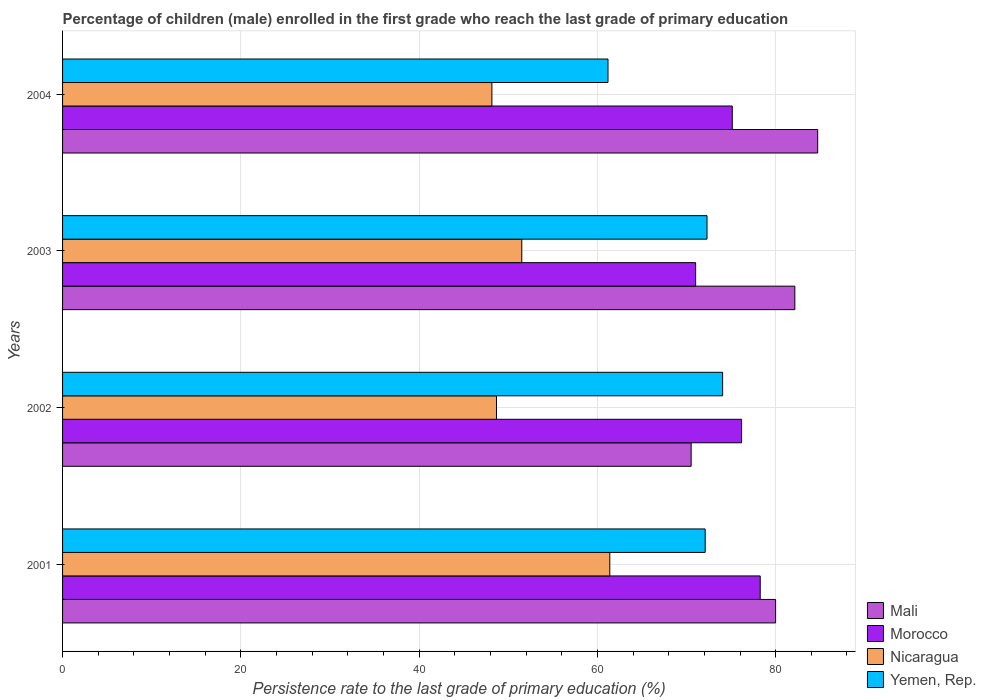How many groups of bars are there?
Provide a succinct answer. 4. How many bars are there on the 2nd tick from the bottom?
Offer a terse response. 4. In how many cases, is the number of bars for a given year not equal to the number of legend labels?
Your response must be concise. 0. What is the persistence rate of children in Mali in 2003?
Make the answer very short. 82.15. Across all years, what is the maximum persistence rate of children in Mali?
Your answer should be compact. 84.71. Across all years, what is the minimum persistence rate of children in Morocco?
Make the answer very short. 71.02. In which year was the persistence rate of children in Mali maximum?
Make the answer very short. 2004. In which year was the persistence rate of children in Morocco minimum?
Ensure brevity in your answer.  2003. What is the total persistence rate of children in Morocco in the graph?
Provide a succinct answer. 300.59. What is the difference between the persistence rate of children in Nicaragua in 2002 and that in 2004?
Offer a very short reply. 0.52. What is the difference between the persistence rate of children in Mali in 2001 and the persistence rate of children in Nicaragua in 2002?
Offer a very short reply. 31.31. What is the average persistence rate of children in Nicaragua per year?
Make the answer very short. 52.44. In the year 2001, what is the difference between the persistence rate of children in Nicaragua and persistence rate of children in Mali?
Make the answer very short. -18.6. What is the ratio of the persistence rate of children in Nicaragua in 2001 to that in 2003?
Keep it short and to the point. 1.19. Is the persistence rate of children in Yemen, Rep. in 2002 less than that in 2004?
Give a very brief answer. No. What is the difference between the highest and the second highest persistence rate of children in Nicaragua?
Offer a terse response. 9.87. What is the difference between the highest and the lowest persistence rate of children in Morocco?
Offer a very short reply. 7.24. In how many years, is the persistence rate of children in Mali greater than the average persistence rate of children in Mali taken over all years?
Offer a very short reply. 3. Is it the case that in every year, the sum of the persistence rate of children in Morocco and persistence rate of children in Yemen, Rep. is greater than the sum of persistence rate of children in Mali and persistence rate of children in Nicaragua?
Give a very brief answer. No. What does the 1st bar from the top in 2002 represents?
Your answer should be compact. Yemen, Rep. What does the 1st bar from the bottom in 2002 represents?
Ensure brevity in your answer.  Mali. How many bars are there?
Provide a short and direct response. 16. How many years are there in the graph?
Provide a short and direct response. 4. Does the graph contain grids?
Give a very brief answer. Yes. How many legend labels are there?
Ensure brevity in your answer.  4. How are the legend labels stacked?
Your response must be concise. Vertical. What is the title of the graph?
Provide a succinct answer. Percentage of children (male) enrolled in the first grade who reach the last grade of primary education. What is the label or title of the X-axis?
Ensure brevity in your answer.  Persistence rate to the last grade of primary education (%). What is the label or title of the Y-axis?
Make the answer very short. Years. What is the Persistence rate to the last grade of primary education (%) of Mali in 2001?
Keep it short and to the point. 79.99. What is the Persistence rate to the last grade of primary education (%) in Morocco in 2001?
Offer a very short reply. 78.27. What is the Persistence rate to the last grade of primary education (%) of Nicaragua in 2001?
Provide a succinct answer. 61.39. What is the Persistence rate to the last grade of primary education (%) of Yemen, Rep. in 2001?
Offer a terse response. 72.09. What is the Persistence rate to the last grade of primary education (%) of Mali in 2002?
Give a very brief answer. 70.52. What is the Persistence rate to the last grade of primary education (%) of Morocco in 2002?
Offer a terse response. 76.17. What is the Persistence rate to the last grade of primary education (%) of Nicaragua in 2002?
Your answer should be compact. 48.68. What is the Persistence rate to the last grade of primary education (%) of Yemen, Rep. in 2002?
Provide a succinct answer. 74.05. What is the Persistence rate to the last grade of primary education (%) in Mali in 2003?
Offer a terse response. 82.15. What is the Persistence rate to the last grade of primary education (%) of Morocco in 2003?
Keep it short and to the point. 71.02. What is the Persistence rate to the last grade of primary education (%) of Nicaragua in 2003?
Ensure brevity in your answer.  51.52. What is the Persistence rate to the last grade of primary education (%) of Yemen, Rep. in 2003?
Offer a very short reply. 72.3. What is the Persistence rate to the last grade of primary education (%) in Mali in 2004?
Your answer should be compact. 84.71. What is the Persistence rate to the last grade of primary education (%) in Morocco in 2004?
Provide a succinct answer. 75.13. What is the Persistence rate to the last grade of primary education (%) of Nicaragua in 2004?
Your answer should be compact. 48.16. What is the Persistence rate to the last grade of primary education (%) in Yemen, Rep. in 2004?
Make the answer very short. 61.19. Across all years, what is the maximum Persistence rate to the last grade of primary education (%) in Mali?
Ensure brevity in your answer.  84.71. Across all years, what is the maximum Persistence rate to the last grade of primary education (%) in Morocco?
Offer a terse response. 78.27. Across all years, what is the maximum Persistence rate to the last grade of primary education (%) of Nicaragua?
Your answer should be compact. 61.39. Across all years, what is the maximum Persistence rate to the last grade of primary education (%) in Yemen, Rep.?
Give a very brief answer. 74.05. Across all years, what is the minimum Persistence rate to the last grade of primary education (%) in Mali?
Make the answer very short. 70.52. Across all years, what is the minimum Persistence rate to the last grade of primary education (%) of Morocco?
Offer a terse response. 71.02. Across all years, what is the minimum Persistence rate to the last grade of primary education (%) of Nicaragua?
Your response must be concise. 48.16. Across all years, what is the minimum Persistence rate to the last grade of primary education (%) of Yemen, Rep.?
Your answer should be compact. 61.19. What is the total Persistence rate to the last grade of primary education (%) in Mali in the graph?
Make the answer very short. 317.37. What is the total Persistence rate to the last grade of primary education (%) of Morocco in the graph?
Offer a terse response. 300.59. What is the total Persistence rate to the last grade of primary education (%) in Nicaragua in the graph?
Provide a succinct answer. 209.75. What is the total Persistence rate to the last grade of primary education (%) of Yemen, Rep. in the graph?
Offer a terse response. 279.63. What is the difference between the Persistence rate to the last grade of primary education (%) in Mali in 2001 and that in 2002?
Offer a terse response. 9.48. What is the difference between the Persistence rate to the last grade of primary education (%) of Morocco in 2001 and that in 2002?
Offer a very short reply. 2.09. What is the difference between the Persistence rate to the last grade of primary education (%) in Nicaragua in 2001 and that in 2002?
Ensure brevity in your answer.  12.71. What is the difference between the Persistence rate to the last grade of primary education (%) in Yemen, Rep. in 2001 and that in 2002?
Provide a short and direct response. -1.96. What is the difference between the Persistence rate to the last grade of primary education (%) in Mali in 2001 and that in 2003?
Your answer should be very brief. -2.16. What is the difference between the Persistence rate to the last grade of primary education (%) in Morocco in 2001 and that in 2003?
Your answer should be very brief. 7.24. What is the difference between the Persistence rate to the last grade of primary education (%) of Nicaragua in 2001 and that in 2003?
Provide a succinct answer. 9.87. What is the difference between the Persistence rate to the last grade of primary education (%) of Yemen, Rep. in 2001 and that in 2003?
Your answer should be compact. -0.21. What is the difference between the Persistence rate to the last grade of primary education (%) of Mali in 2001 and that in 2004?
Make the answer very short. -4.72. What is the difference between the Persistence rate to the last grade of primary education (%) in Morocco in 2001 and that in 2004?
Offer a terse response. 3.14. What is the difference between the Persistence rate to the last grade of primary education (%) of Nicaragua in 2001 and that in 2004?
Your answer should be compact. 13.23. What is the difference between the Persistence rate to the last grade of primary education (%) of Yemen, Rep. in 2001 and that in 2004?
Give a very brief answer. 10.9. What is the difference between the Persistence rate to the last grade of primary education (%) of Mali in 2002 and that in 2003?
Your response must be concise. -11.63. What is the difference between the Persistence rate to the last grade of primary education (%) of Morocco in 2002 and that in 2003?
Your answer should be compact. 5.15. What is the difference between the Persistence rate to the last grade of primary education (%) of Nicaragua in 2002 and that in 2003?
Give a very brief answer. -2.84. What is the difference between the Persistence rate to the last grade of primary education (%) in Yemen, Rep. in 2002 and that in 2003?
Your answer should be compact. 1.75. What is the difference between the Persistence rate to the last grade of primary education (%) of Mali in 2002 and that in 2004?
Ensure brevity in your answer.  -14.2. What is the difference between the Persistence rate to the last grade of primary education (%) of Morocco in 2002 and that in 2004?
Your answer should be compact. 1.05. What is the difference between the Persistence rate to the last grade of primary education (%) of Nicaragua in 2002 and that in 2004?
Your response must be concise. 0.52. What is the difference between the Persistence rate to the last grade of primary education (%) of Yemen, Rep. in 2002 and that in 2004?
Offer a terse response. 12.86. What is the difference between the Persistence rate to the last grade of primary education (%) in Mali in 2003 and that in 2004?
Ensure brevity in your answer.  -2.56. What is the difference between the Persistence rate to the last grade of primary education (%) in Morocco in 2003 and that in 2004?
Provide a succinct answer. -4.11. What is the difference between the Persistence rate to the last grade of primary education (%) in Nicaragua in 2003 and that in 2004?
Ensure brevity in your answer.  3.35. What is the difference between the Persistence rate to the last grade of primary education (%) in Yemen, Rep. in 2003 and that in 2004?
Give a very brief answer. 11.11. What is the difference between the Persistence rate to the last grade of primary education (%) of Mali in 2001 and the Persistence rate to the last grade of primary education (%) of Morocco in 2002?
Give a very brief answer. 3.82. What is the difference between the Persistence rate to the last grade of primary education (%) in Mali in 2001 and the Persistence rate to the last grade of primary education (%) in Nicaragua in 2002?
Your response must be concise. 31.31. What is the difference between the Persistence rate to the last grade of primary education (%) in Mali in 2001 and the Persistence rate to the last grade of primary education (%) in Yemen, Rep. in 2002?
Make the answer very short. 5.94. What is the difference between the Persistence rate to the last grade of primary education (%) of Morocco in 2001 and the Persistence rate to the last grade of primary education (%) of Nicaragua in 2002?
Make the answer very short. 29.58. What is the difference between the Persistence rate to the last grade of primary education (%) in Morocco in 2001 and the Persistence rate to the last grade of primary education (%) in Yemen, Rep. in 2002?
Your answer should be very brief. 4.22. What is the difference between the Persistence rate to the last grade of primary education (%) in Nicaragua in 2001 and the Persistence rate to the last grade of primary education (%) in Yemen, Rep. in 2002?
Provide a short and direct response. -12.66. What is the difference between the Persistence rate to the last grade of primary education (%) in Mali in 2001 and the Persistence rate to the last grade of primary education (%) in Morocco in 2003?
Make the answer very short. 8.97. What is the difference between the Persistence rate to the last grade of primary education (%) of Mali in 2001 and the Persistence rate to the last grade of primary education (%) of Nicaragua in 2003?
Your answer should be very brief. 28.48. What is the difference between the Persistence rate to the last grade of primary education (%) of Mali in 2001 and the Persistence rate to the last grade of primary education (%) of Yemen, Rep. in 2003?
Provide a short and direct response. 7.7. What is the difference between the Persistence rate to the last grade of primary education (%) in Morocco in 2001 and the Persistence rate to the last grade of primary education (%) in Nicaragua in 2003?
Make the answer very short. 26.75. What is the difference between the Persistence rate to the last grade of primary education (%) in Morocco in 2001 and the Persistence rate to the last grade of primary education (%) in Yemen, Rep. in 2003?
Keep it short and to the point. 5.97. What is the difference between the Persistence rate to the last grade of primary education (%) in Nicaragua in 2001 and the Persistence rate to the last grade of primary education (%) in Yemen, Rep. in 2003?
Your answer should be compact. -10.91. What is the difference between the Persistence rate to the last grade of primary education (%) in Mali in 2001 and the Persistence rate to the last grade of primary education (%) in Morocco in 2004?
Offer a terse response. 4.86. What is the difference between the Persistence rate to the last grade of primary education (%) of Mali in 2001 and the Persistence rate to the last grade of primary education (%) of Nicaragua in 2004?
Offer a very short reply. 31.83. What is the difference between the Persistence rate to the last grade of primary education (%) in Mali in 2001 and the Persistence rate to the last grade of primary education (%) in Yemen, Rep. in 2004?
Ensure brevity in your answer.  18.8. What is the difference between the Persistence rate to the last grade of primary education (%) in Morocco in 2001 and the Persistence rate to the last grade of primary education (%) in Nicaragua in 2004?
Your answer should be very brief. 30.1. What is the difference between the Persistence rate to the last grade of primary education (%) in Morocco in 2001 and the Persistence rate to the last grade of primary education (%) in Yemen, Rep. in 2004?
Give a very brief answer. 17.08. What is the difference between the Persistence rate to the last grade of primary education (%) of Nicaragua in 2001 and the Persistence rate to the last grade of primary education (%) of Yemen, Rep. in 2004?
Your answer should be compact. 0.2. What is the difference between the Persistence rate to the last grade of primary education (%) in Mali in 2002 and the Persistence rate to the last grade of primary education (%) in Morocco in 2003?
Your answer should be very brief. -0.5. What is the difference between the Persistence rate to the last grade of primary education (%) in Mali in 2002 and the Persistence rate to the last grade of primary education (%) in Nicaragua in 2003?
Give a very brief answer. 19. What is the difference between the Persistence rate to the last grade of primary education (%) in Mali in 2002 and the Persistence rate to the last grade of primary education (%) in Yemen, Rep. in 2003?
Give a very brief answer. -1.78. What is the difference between the Persistence rate to the last grade of primary education (%) in Morocco in 2002 and the Persistence rate to the last grade of primary education (%) in Nicaragua in 2003?
Provide a short and direct response. 24.66. What is the difference between the Persistence rate to the last grade of primary education (%) in Morocco in 2002 and the Persistence rate to the last grade of primary education (%) in Yemen, Rep. in 2003?
Ensure brevity in your answer.  3.88. What is the difference between the Persistence rate to the last grade of primary education (%) of Nicaragua in 2002 and the Persistence rate to the last grade of primary education (%) of Yemen, Rep. in 2003?
Offer a very short reply. -23.62. What is the difference between the Persistence rate to the last grade of primary education (%) in Mali in 2002 and the Persistence rate to the last grade of primary education (%) in Morocco in 2004?
Your response must be concise. -4.61. What is the difference between the Persistence rate to the last grade of primary education (%) in Mali in 2002 and the Persistence rate to the last grade of primary education (%) in Nicaragua in 2004?
Give a very brief answer. 22.35. What is the difference between the Persistence rate to the last grade of primary education (%) in Mali in 2002 and the Persistence rate to the last grade of primary education (%) in Yemen, Rep. in 2004?
Keep it short and to the point. 9.33. What is the difference between the Persistence rate to the last grade of primary education (%) of Morocco in 2002 and the Persistence rate to the last grade of primary education (%) of Nicaragua in 2004?
Make the answer very short. 28.01. What is the difference between the Persistence rate to the last grade of primary education (%) of Morocco in 2002 and the Persistence rate to the last grade of primary education (%) of Yemen, Rep. in 2004?
Ensure brevity in your answer.  14.98. What is the difference between the Persistence rate to the last grade of primary education (%) in Nicaragua in 2002 and the Persistence rate to the last grade of primary education (%) in Yemen, Rep. in 2004?
Offer a very short reply. -12.51. What is the difference between the Persistence rate to the last grade of primary education (%) of Mali in 2003 and the Persistence rate to the last grade of primary education (%) of Morocco in 2004?
Your answer should be compact. 7.02. What is the difference between the Persistence rate to the last grade of primary education (%) of Mali in 2003 and the Persistence rate to the last grade of primary education (%) of Nicaragua in 2004?
Provide a succinct answer. 33.99. What is the difference between the Persistence rate to the last grade of primary education (%) of Mali in 2003 and the Persistence rate to the last grade of primary education (%) of Yemen, Rep. in 2004?
Make the answer very short. 20.96. What is the difference between the Persistence rate to the last grade of primary education (%) of Morocco in 2003 and the Persistence rate to the last grade of primary education (%) of Nicaragua in 2004?
Your response must be concise. 22.86. What is the difference between the Persistence rate to the last grade of primary education (%) in Morocco in 2003 and the Persistence rate to the last grade of primary education (%) in Yemen, Rep. in 2004?
Provide a succinct answer. 9.83. What is the difference between the Persistence rate to the last grade of primary education (%) of Nicaragua in 2003 and the Persistence rate to the last grade of primary education (%) of Yemen, Rep. in 2004?
Your answer should be very brief. -9.67. What is the average Persistence rate to the last grade of primary education (%) of Mali per year?
Give a very brief answer. 79.34. What is the average Persistence rate to the last grade of primary education (%) in Morocco per year?
Your answer should be compact. 75.15. What is the average Persistence rate to the last grade of primary education (%) of Nicaragua per year?
Your answer should be very brief. 52.44. What is the average Persistence rate to the last grade of primary education (%) of Yemen, Rep. per year?
Keep it short and to the point. 69.91. In the year 2001, what is the difference between the Persistence rate to the last grade of primary education (%) of Mali and Persistence rate to the last grade of primary education (%) of Morocco?
Your answer should be compact. 1.73. In the year 2001, what is the difference between the Persistence rate to the last grade of primary education (%) in Mali and Persistence rate to the last grade of primary education (%) in Nicaragua?
Provide a short and direct response. 18.6. In the year 2001, what is the difference between the Persistence rate to the last grade of primary education (%) of Mali and Persistence rate to the last grade of primary education (%) of Yemen, Rep.?
Ensure brevity in your answer.  7.9. In the year 2001, what is the difference between the Persistence rate to the last grade of primary education (%) of Morocco and Persistence rate to the last grade of primary education (%) of Nicaragua?
Your response must be concise. 16.87. In the year 2001, what is the difference between the Persistence rate to the last grade of primary education (%) in Morocco and Persistence rate to the last grade of primary education (%) in Yemen, Rep.?
Your answer should be very brief. 6.18. In the year 2001, what is the difference between the Persistence rate to the last grade of primary education (%) in Nicaragua and Persistence rate to the last grade of primary education (%) in Yemen, Rep.?
Your answer should be compact. -10.7. In the year 2002, what is the difference between the Persistence rate to the last grade of primary education (%) of Mali and Persistence rate to the last grade of primary education (%) of Morocco?
Give a very brief answer. -5.66. In the year 2002, what is the difference between the Persistence rate to the last grade of primary education (%) of Mali and Persistence rate to the last grade of primary education (%) of Nicaragua?
Provide a short and direct response. 21.84. In the year 2002, what is the difference between the Persistence rate to the last grade of primary education (%) in Mali and Persistence rate to the last grade of primary education (%) in Yemen, Rep.?
Your answer should be compact. -3.53. In the year 2002, what is the difference between the Persistence rate to the last grade of primary education (%) of Morocco and Persistence rate to the last grade of primary education (%) of Nicaragua?
Offer a terse response. 27.49. In the year 2002, what is the difference between the Persistence rate to the last grade of primary education (%) in Morocco and Persistence rate to the last grade of primary education (%) in Yemen, Rep.?
Offer a terse response. 2.13. In the year 2002, what is the difference between the Persistence rate to the last grade of primary education (%) in Nicaragua and Persistence rate to the last grade of primary education (%) in Yemen, Rep.?
Provide a short and direct response. -25.37. In the year 2003, what is the difference between the Persistence rate to the last grade of primary education (%) in Mali and Persistence rate to the last grade of primary education (%) in Morocco?
Your response must be concise. 11.13. In the year 2003, what is the difference between the Persistence rate to the last grade of primary education (%) in Mali and Persistence rate to the last grade of primary education (%) in Nicaragua?
Your answer should be very brief. 30.63. In the year 2003, what is the difference between the Persistence rate to the last grade of primary education (%) of Mali and Persistence rate to the last grade of primary education (%) of Yemen, Rep.?
Your answer should be compact. 9.85. In the year 2003, what is the difference between the Persistence rate to the last grade of primary education (%) in Morocco and Persistence rate to the last grade of primary education (%) in Nicaragua?
Your answer should be very brief. 19.5. In the year 2003, what is the difference between the Persistence rate to the last grade of primary education (%) of Morocco and Persistence rate to the last grade of primary education (%) of Yemen, Rep.?
Ensure brevity in your answer.  -1.28. In the year 2003, what is the difference between the Persistence rate to the last grade of primary education (%) in Nicaragua and Persistence rate to the last grade of primary education (%) in Yemen, Rep.?
Offer a terse response. -20.78. In the year 2004, what is the difference between the Persistence rate to the last grade of primary education (%) of Mali and Persistence rate to the last grade of primary education (%) of Morocco?
Keep it short and to the point. 9.58. In the year 2004, what is the difference between the Persistence rate to the last grade of primary education (%) in Mali and Persistence rate to the last grade of primary education (%) in Nicaragua?
Your answer should be compact. 36.55. In the year 2004, what is the difference between the Persistence rate to the last grade of primary education (%) in Mali and Persistence rate to the last grade of primary education (%) in Yemen, Rep.?
Provide a succinct answer. 23.52. In the year 2004, what is the difference between the Persistence rate to the last grade of primary education (%) in Morocco and Persistence rate to the last grade of primary education (%) in Nicaragua?
Offer a terse response. 26.97. In the year 2004, what is the difference between the Persistence rate to the last grade of primary education (%) of Morocco and Persistence rate to the last grade of primary education (%) of Yemen, Rep.?
Provide a short and direct response. 13.94. In the year 2004, what is the difference between the Persistence rate to the last grade of primary education (%) in Nicaragua and Persistence rate to the last grade of primary education (%) in Yemen, Rep.?
Ensure brevity in your answer.  -13.03. What is the ratio of the Persistence rate to the last grade of primary education (%) of Mali in 2001 to that in 2002?
Offer a terse response. 1.13. What is the ratio of the Persistence rate to the last grade of primary education (%) of Morocco in 2001 to that in 2002?
Keep it short and to the point. 1.03. What is the ratio of the Persistence rate to the last grade of primary education (%) of Nicaragua in 2001 to that in 2002?
Your answer should be compact. 1.26. What is the ratio of the Persistence rate to the last grade of primary education (%) in Yemen, Rep. in 2001 to that in 2002?
Offer a very short reply. 0.97. What is the ratio of the Persistence rate to the last grade of primary education (%) of Mali in 2001 to that in 2003?
Keep it short and to the point. 0.97. What is the ratio of the Persistence rate to the last grade of primary education (%) of Morocco in 2001 to that in 2003?
Your answer should be compact. 1.1. What is the ratio of the Persistence rate to the last grade of primary education (%) in Nicaragua in 2001 to that in 2003?
Your response must be concise. 1.19. What is the ratio of the Persistence rate to the last grade of primary education (%) in Yemen, Rep. in 2001 to that in 2003?
Make the answer very short. 1. What is the ratio of the Persistence rate to the last grade of primary education (%) in Mali in 2001 to that in 2004?
Keep it short and to the point. 0.94. What is the ratio of the Persistence rate to the last grade of primary education (%) in Morocco in 2001 to that in 2004?
Your answer should be very brief. 1.04. What is the ratio of the Persistence rate to the last grade of primary education (%) in Nicaragua in 2001 to that in 2004?
Provide a short and direct response. 1.27. What is the ratio of the Persistence rate to the last grade of primary education (%) in Yemen, Rep. in 2001 to that in 2004?
Your response must be concise. 1.18. What is the ratio of the Persistence rate to the last grade of primary education (%) of Mali in 2002 to that in 2003?
Give a very brief answer. 0.86. What is the ratio of the Persistence rate to the last grade of primary education (%) of Morocco in 2002 to that in 2003?
Offer a terse response. 1.07. What is the ratio of the Persistence rate to the last grade of primary education (%) in Nicaragua in 2002 to that in 2003?
Provide a short and direct response. 0.94. What is the ratio of the Persistence rate to the last grade of primary education (%) of Yemen, Rep. in 2002 to that in 2003?
Provide a short and direct response. 1.02. What is the ratio of the Persistence rate to the last grade of primary education (%) of Mali in 2002 to that in 2004?
Offer a very short reply. 0.83. What is the ratio of the Persistence rate to the last grade of primary education (%) of Morocco in 2002 to that in 2004?
Your answer should be compact. 1.01. What is the ratio of the Persistence rate to the last grade of primary education (%) of Nicaragua in 2002 to that in 2004?
Ensure brevity in your answer.  1.01. What is the ratio of the Persistence rate to the last grade of primary education (%) in Yemen, Rep. in 2002 to that in 2004?
Your answer should be compact. 1.21. What is the ratio of the Persistence rate to the last grade of primary education (%) of Mali in 2003 to that in 2004?
Your answer should be very brief. 0.97. What is the ratio of the Persistence rate to the last grade of primary education (%) of Morocco in 2003 to that in 2004?
Offer a very short reply. 0.95. What is the ratio of the Persistence rate to the last grade of primary education (%) of Nicaragua in 2003 to that in 2004?
Provide a short and direct response. 1.07. What is the ratio of the Persistence rate to the last grade of primary education (%) in Yemen, Rep. in 2003 to that in 2004?
Give a very brief answer. 1.18. What is the difference between the highest and the second highest Persistence rate to the last grade of primary education (%) in Mali?
Make the answer very short. 2.56. What is the difference between the highest and the second highest Persistence rate to the last grade of primary education (%) of Morocco?
Ensure brevity in your answer.  2.09. What is the difference between the highest and the second highest Persistence rate to the last grade of primary education (%) in Nicaragua?
Provide a succinct answer. 9.87. What is the difference between the highest and the second highest Persistence rate to the last grade of primary education (%) of Yemen, Rep.?
Keep it short and to the point. 1.75. What is the difference between the highest and the lowest Persistence rate to the last grade of primary education (%) in Mali?
Your response must be concise. 14.2. What is the difference between the highest and the lowest Persistence rate to the last grade of primary education (%) of Morocco?
Offer a terse response. 7.24. What is the difference between the highest and the lowest Persistence rate to the last grade of primary education (%) in Nicaragua?
Your answer should be very brief. 13.23. What is the difference between the highest and the lowest Persistence rate to the last grade of primary education (%) of Yemen, Rep.?
Your answer should be very brief. 12.86. 